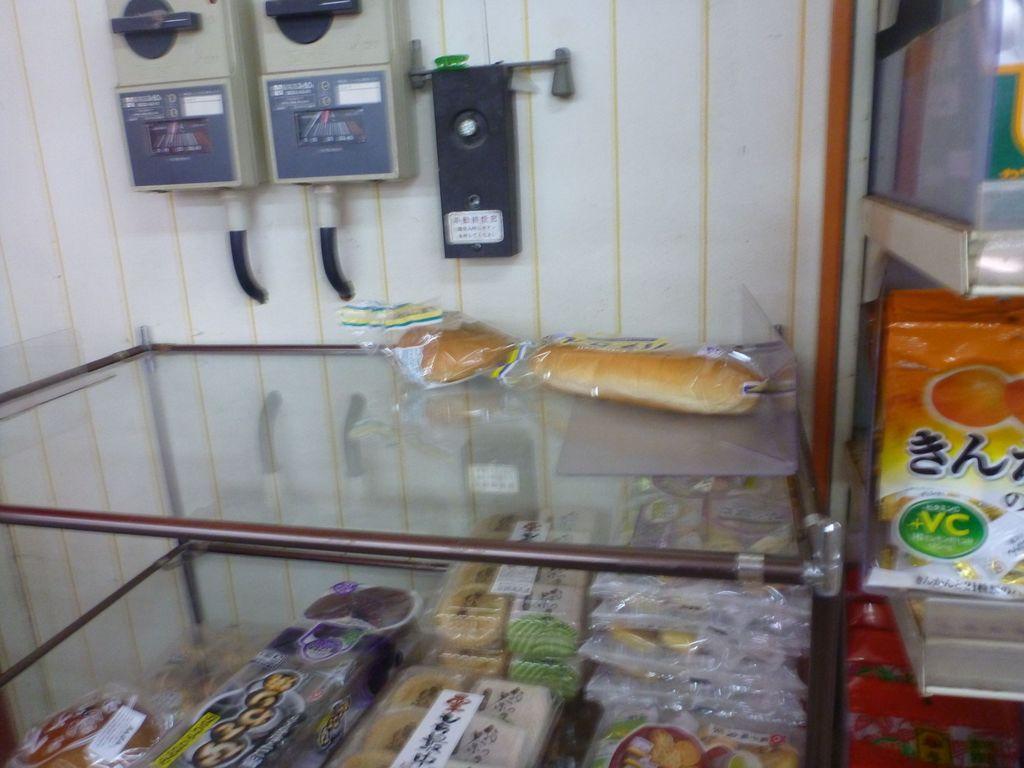Can you describe this image briefly? In this picture we can see some food packets inside the glass container and a few food packets on the glass container. There are some electronic devices on the wall. We can see a few boxes on the right side. 